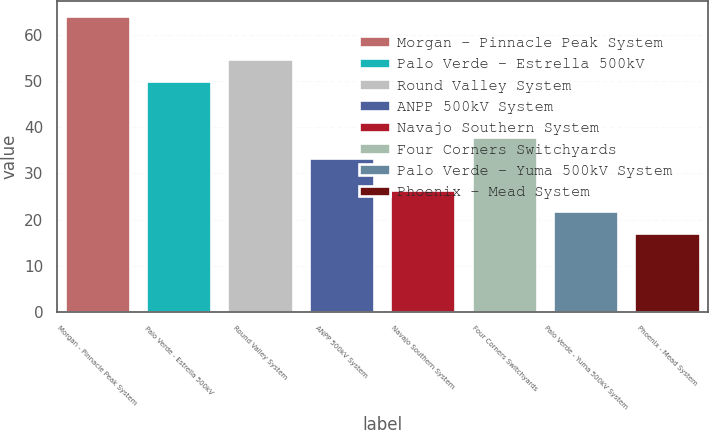Convert chart to OTSL. <chart><loc_0><loc_0><loc_500><loc_500><bar_chart><fcel>Morgan - Pinnacle Peak System<fcel>Palo Verde - Estrella 500kV<fcel>Round Valley System<fcel>ANPP 500kV System<fcel>Navajo Southern System<fcel>Four Corners Switchyards<fcel>Palo Verde - Yuma 500kV System<fcel>Phoenix - Mead System<nl><fcel>64.1<fcel>50<fcel>54.7<fcel>33.3<fcel>26.5<fcel>38<fcel>21.8<fcel>17.1<nl></chart> 